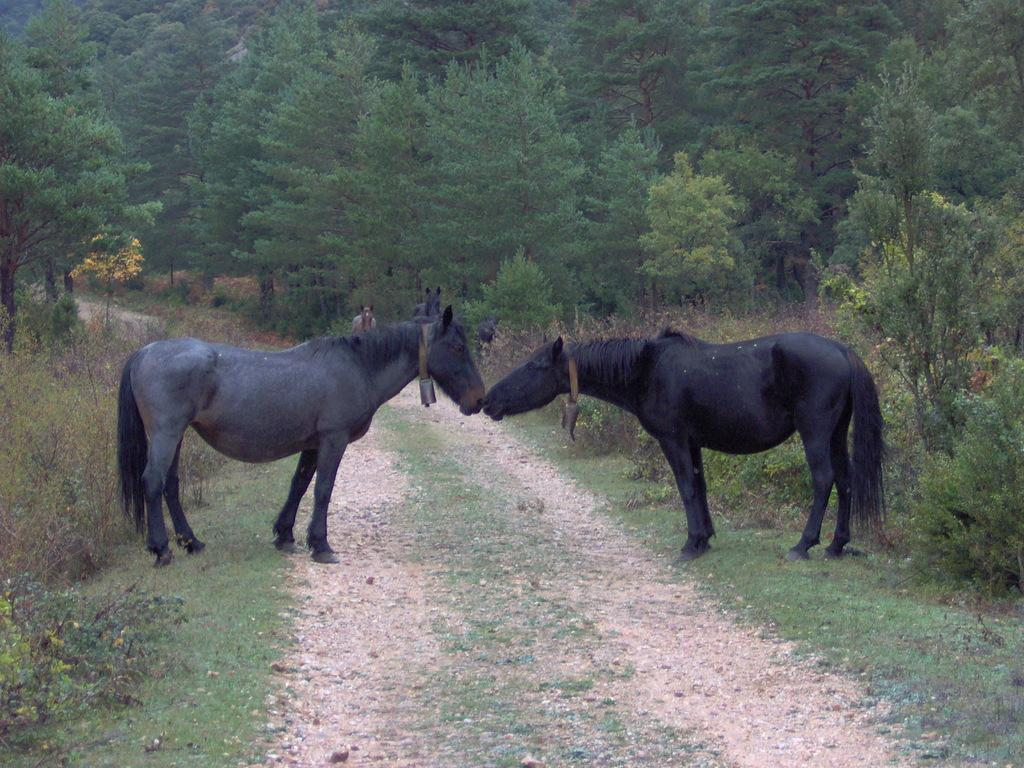What type of surface is visible in the image? There is a road in the image. What type of vegetation is present on the ground in the image? There is grass on the ground in the image. What animals can be seen in the image? There are horses in the image. What other types of vegetation are present in the image? There are trees and plants in the image. Can you describe the background of the image? There is a person in the background of the image. How many lizards are sitting on the cart in the image? There is no cart or lizards present in the image. What type of rabbit can be seen interacting with the person in the background? There is no rabbit present in the image; only a person is visible in the background. 